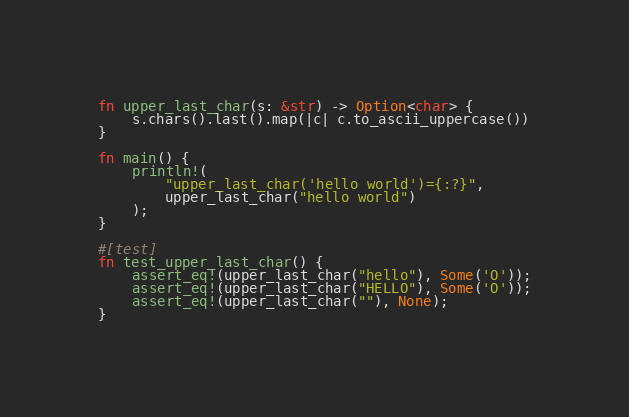<code> <loc_0><loc_0><loc_500><loc_500><_Rust_>fn upper_last_char(s: &str) -> Option<char> {
    s.chars().last().map(|c| c.to_ascii_uppercase())
}

fn main() {
    println!(
        "upper_last_char('hello world')={:?}",
        upper_last_char("hello world")
    );
}

#[test]
fn test_upper_last_char() {
    assert_eq!(upper_last_char("hello"), Some('O'));
    assert_eq!(upper_last_char("HELLO"), Some('O'));
    assert_eq!(upper_last_char(""), None);
}
</code> 